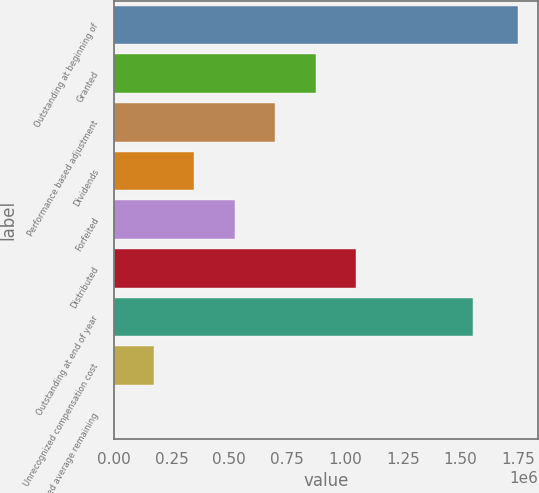Convert chart. <chart><loc_0><loc_0><loc_500><loc_500><bar_chart><fcel>Outstanding at beginning of<fcel>Granted<fcel>Performance based adjustment<fcel>Dividends<fcel>Forfeited<fcel>Distributed<fcel>Outstanding at end of year<fcel>Unrecognized compensation cost<fcel>Weighted average remaining<nl><fcel>1.74651e+06<fcel>873256<fcel>698605<fcel>349304<fcel>523955<fcel>1.04791e+06<fcel>1.55173e+06<fcel>174653<fcel>1.8<nl></chart> 